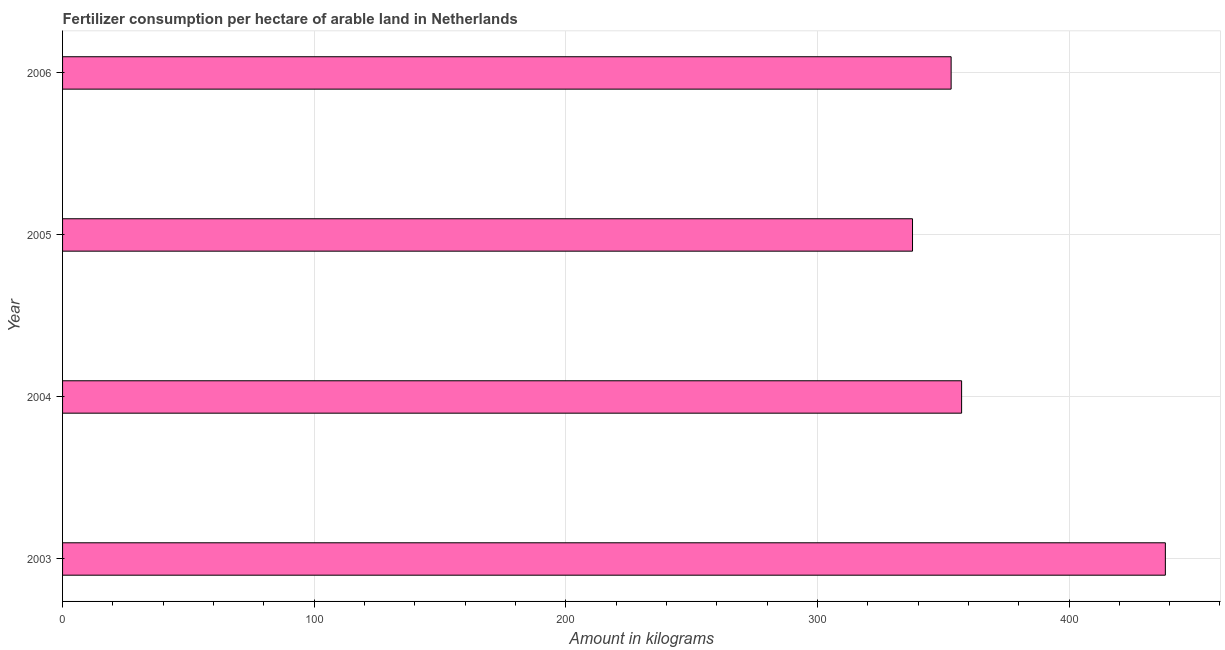What is the title of the graph?
Offer a very short reply. Fertilizer consumption per hectare of arable land in Netherlands . What is the label or title of the X-axis?
Provide a succinct answer. Amount in kilograms. What is the label or title of the Y-axis?
Keep it short and to the point. Year. What is the amount of fertilizer consumption in 2005?
Ensure brevity in your answer.  337.81. Across all years, what is the maximum amount of fertilizer consumption?
Provide a succinct answer. 438.29. Across all years, what is the minimum amount of fertilizer consumption?
Give a very brief answer. 337.81. In which year was the amount of fertilizer consumption maximum?
Give a very brief answer. 2003. In which year was the amount of fertilizer consumption minimum?
Make the answer very short. 2005. What is the sum of the amount of fertilizer consumption?
Your answer should be very brief. 1486.56. What is the difference between the amount of fertilizer consumption in 2003 and 2004?
Your answer should be compact. 80.98. What is the average amount of fertilizer consumption per year?
Your response must be concise. 371.64. What is the median amount of fertilizer consumption?
Give a very brief answer. 355.23. What is the ratio of the amount of fertilizer consumption in 2003 to that in 2006?
Make the answer very short. 1.24. Is the amount of fertilizer consumption in 2003 less than that in 2006?
Provide a short and direct response. No. Is the difference between the amount of fertilizer consumption in 2005 and 2006 greater than the difference between any two years?
Make the answer very short. No. What is the difference between the highest and the second highest amount of fertilizer consumption?
Ensure brevity in your answer.  80.98. Is the sum of the amount of fertilizer consumption in 2004 and 2006 greater than the maximum amount of fertilizer consumption across all years?
Offer a very short reply. Yes. What is the difference between the highest and the lowest amount of fertilizer consumption?
Your answer should be compact. 100.48. How many bars are there?
Give a very brief answer. 4. Are all the bars in the graph horizontal?
Give a very brief answer. Yes. What is the Amount in kilograms in 2003?
Your answer should be compact. 438.29. What is the Amount in kilograms of 2004?
Provide a succinct answer. 357.31. What is the Amount in kilograms of 2005?
Keep it short and to the point. 337.81. What is the Amount in kilograms of 2006?
Give a very brief answer. 353.15. What is the difference between the Amount in kilograms in 2003 and 2004?
Your response must be concise. 80.98. What is the difference between the Amount in kilograms in 2003 and 2005?
Keep it short and to the point. 100.48. What is the difference between the Amount in kilograms in 2003 and 2006?
Offer a very short reply. 85.15. What is the difference between the Amount in kilograms in 2004 and 2005?
Offer a very short reply. 19.51. What is the difference between the Amount in kilograms in 2004 and 2006?
Provide a short and direct response. 4.17. What is the difference between the Amount in kilograms in 2005 and 2006?
Offer a terse response. -15.34. What is the ratio of the Amount in kilograms in 2003 to that in 2004?
Make the answer very short. 1.23. What is the ratio of the Amount in kilograms in 2003 to that in 2005?
Offer a terse response. 1.3. What is the ratio of the Amount in kilograms in 2003 to that in 2006?
Provide a short and direct response. 1.24. What is the ratio of the Amount in kilograms in 2004 to that in 2005?
Give a very brief answer. 1.06. What is the ratio of the Amount in kilograms in 2004 to that in 2006?
Your answer should be very brief. 1.01. 